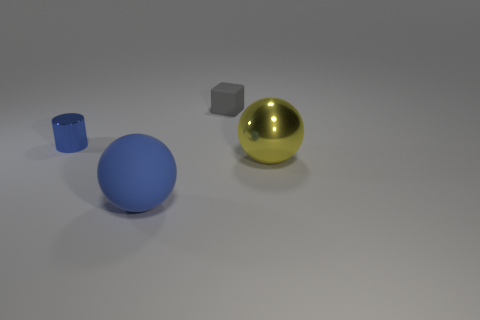Add 3 big matte spheres. How many objects exist? 7 Subtract all blue balls. How many balls are left? 1 Subtract all red spheres. Subtract all gray cubes. How many spheres are left? 2 Subtract all blue blocks. How many yellow cylinders are left? 0 Subtract all tiny gray blocks. Subtract all big rubber spheres. How many objects are left? 2 Add 1 tiny blue metal things. How many tiny blue metal things are left? 2 Add 1 gray matte cubes. How many gray matte cubes exist? 2 Subtract 0 red cubes. How many objects are left? 4 Subtract all cylinders. How many objects are left? 3 